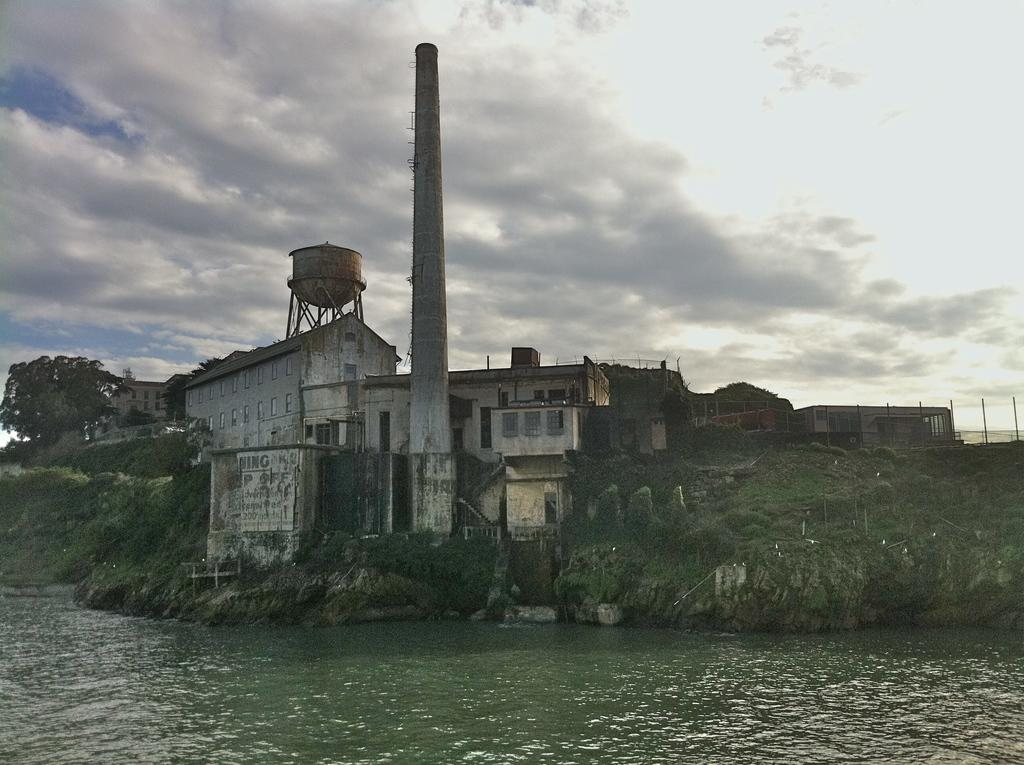What is the main structure in the image? There is a storage tank in the image. What other structures can be seen in the image? There is a tower and buildings in the image. What type of natural feature is present in the image? There are trees on a hill in the image. What is at the bottom of the image? There is water at the bottom of the image. What can be seen in the background of the image? The sky is visible in the background of the image. What type of popcorn is being used as bait in the image? There is no popcorn or bait present in the image. How does the image change when viewed from a different angle? The image does not change when viewed from a different angle, as it is a static image. 